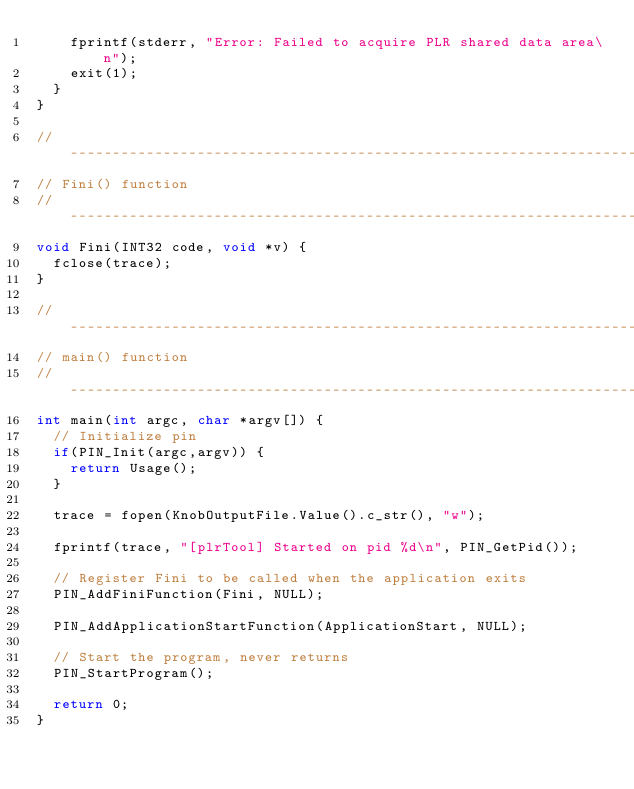Convert code to text. <code><loc_0><loc_0><loc_500><loc_500><_C++_>    fprintf(stderr, "Error: Failed to acquire PLR shared data area\n");
    exit(1);
  }
}
  
//-----------------------------------------------------------------------------
// Fini() function
//-----------------------------------------------------------------------------
void Fini(INT32 code, void *v) {
  fclose(trace);
}

//-----------------------------------------------------------------------------
// main() function
//-----------------------------------------------------------------------------
int main(int argc, char *argv[]) {
  // Initialize pin
  if(PIN_Init(argc,argv)) {
    return Usage();
  }
  
  trace = fopen(KnobOutputFile.Value().c_str(), "w");
  
  fprintf(trace, "[plrTool] Started on pid %d\n", PIN_GetPid());
  
  // Register Fini to be called when the application exits
  PIN_AddFiniFunction(Fini, NULL);
  
  PIN_AddApplicationStartFunction(ApplicationStart, NULL);
  
  // Start the program, never returns
  PIN_StartProgram();
  
  return 0;
}
</code> 